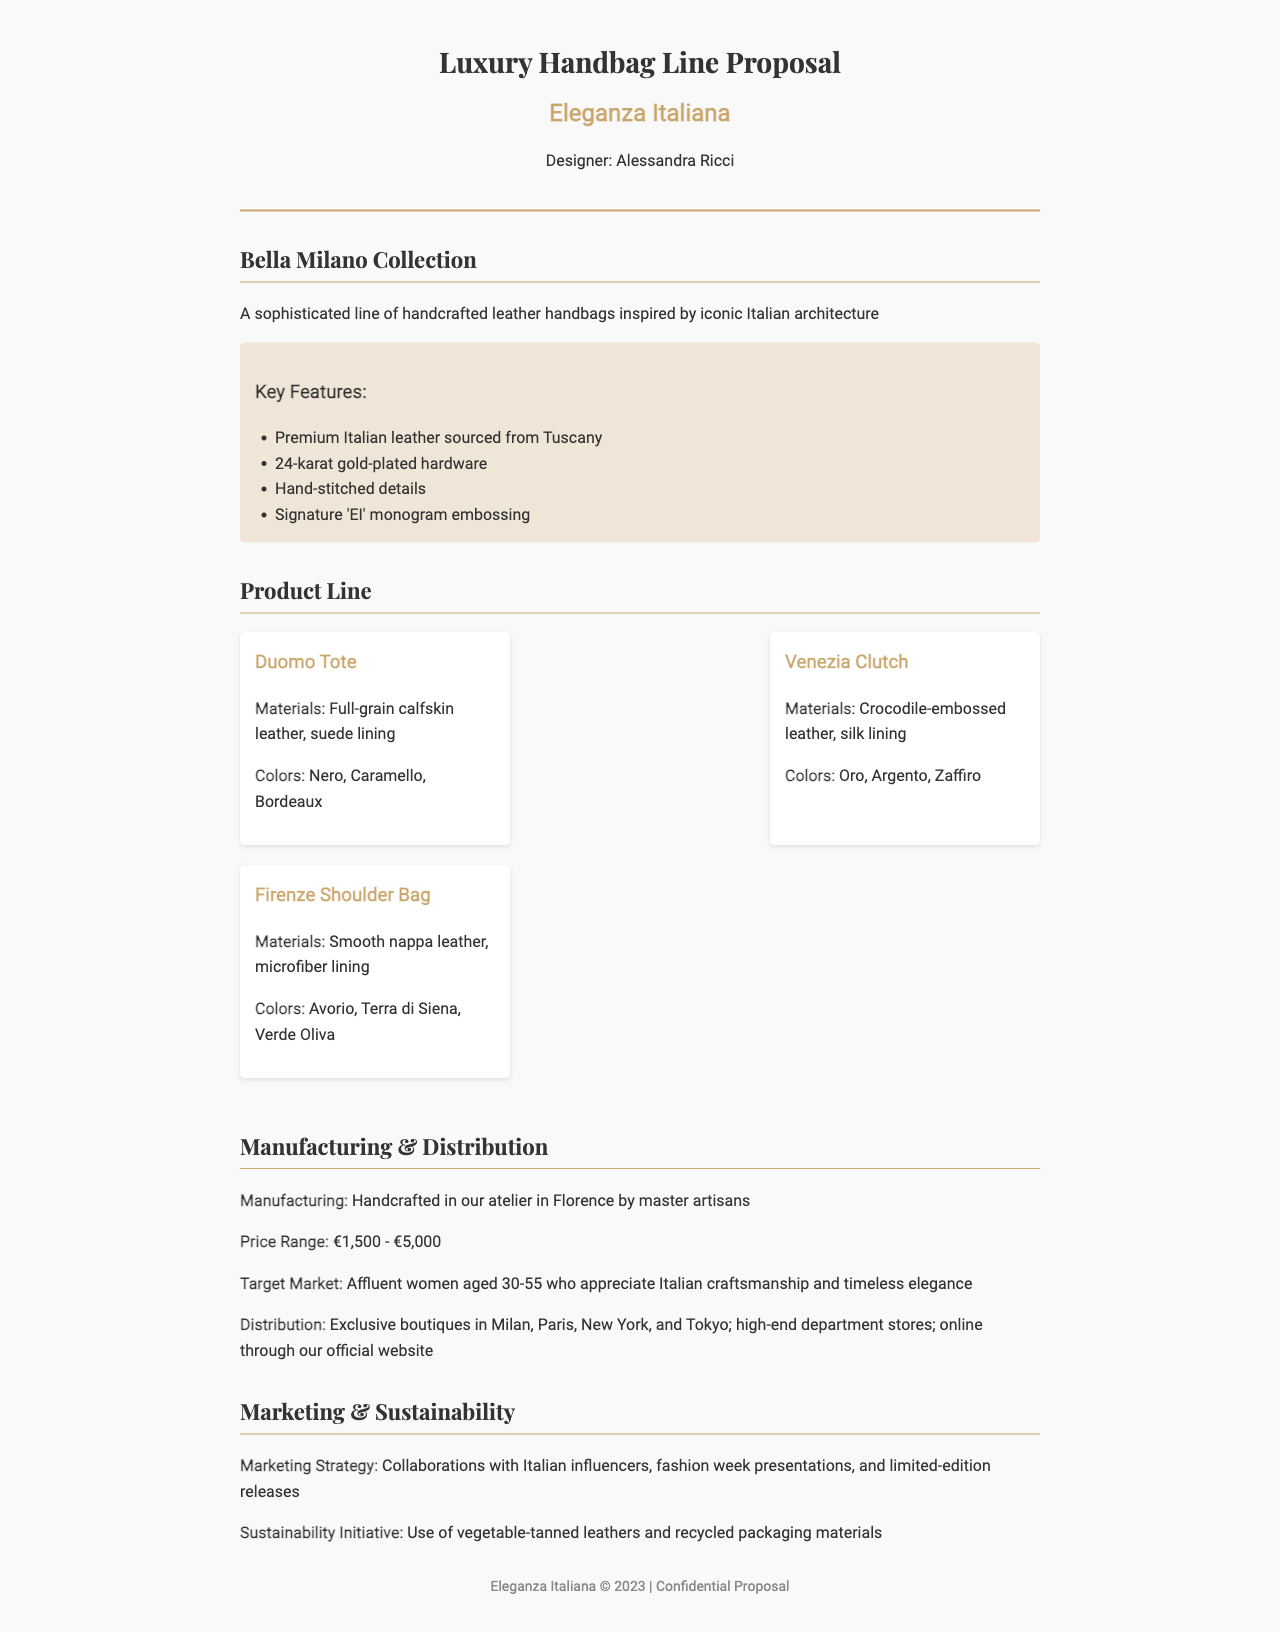What is the name of the handbag collection? The collection name is clearly stated as "Bella Milano Collection" in the document.
Answer: Bella Milano Collection Who is the designer of the handbags? The document specifies "Designer: Alessandra Ricci" prominently in the header.
Answer: Alessandra Ricci What materials are used for the Duomo Tote? The materials for the Duomo Tote are listed in the product section as "Full-grain calfskin leather, suede lining."
Answer: Full-grain calfskin leather, suede lining What is the price range of the handbags? The price range is mentioned in the manufacturing section as "€1,500 - €5,000."
Answer: €1,500 - €5,000 Where are the handbags manufactured? The document states that they are "Handcrafted in our atelier in Florence by master artisans."
Answer: Florence What sustainability initiative is mentioned? The document discusses the "Use of vegetable-tanned leathers and recycled packaging materials" as part of sustainability efforts.
Answer: Use of vegetable-tanned leathers and recycled packaging materials Who is the target market for these handbags? The target market is described as "Affluent women aged 30-55."
Answer: Affluent women aged 30-55 Which hardware is used in the handbags? The document mentions that the handbags feature "24-karat gold-plated hardware."
Answer: 24-karat gold-plated hardware What color options are available for the Venezia Clutch? The color options for the Venezia Clutch are listed as "Oro, Argento, Zaffiro."
Answer: Oro, Argento, Zaffiro 